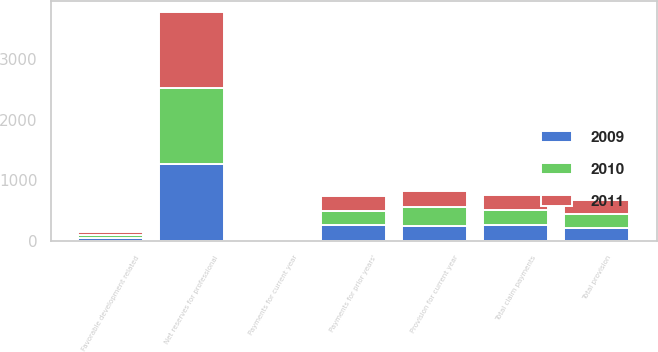Convert chart to OTSL. <chart><loc_0><loc_0><loc_500><loc_500><stacked_bar_chart><ecel><fcel>Net reserves for professional<fcel>Provision for current year<fcel>Favorable development related<fcel>Total provision<fcel>Payments for current year<fcel>Payments for prior years'<fcel>Total claim payments<nl><fcel>2010<fcel>1252<fcel>298<fcel>54<fcel>244<fcel>7<fcel>233<fcel>240<nl><fcel>2011<fcel>1248<fcel>272<fcel>50<fcel>222<fcel>7<fcel>236<fcel>243<nl><fcel>2009<fcel>1269<fcel>258<fcel>47<fcel>211<fcel>4<fcel>268<fcel>272<nl></chart> 